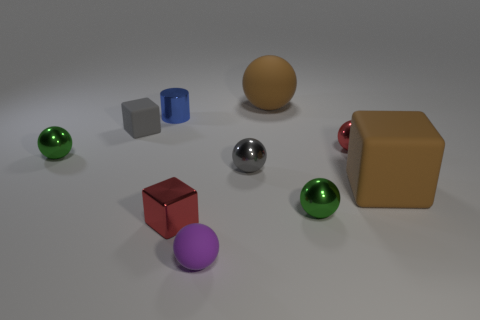Are there any other things that are the same shape as the blue metallic thing?
Make the answer very short. No. What is the size of the brown cube?
Offer a terse response. Large. Is the number of shiny cylinders that are on the right side of the large brown sphere less than the number of yellow cylinders?
Make the answer very short. No. Does the small cylinder have the same material as the small green sphere left of the tiny blue metallic cylinder?
Your response must be concise. Yes. Are there any large brown matte things in front of the rubber cube behind the green ball behind the gray metal ball?
Ensure brevity in your answer.  Yes. What is the color of the tiny cylinder that is made of the same material as the tiny red ball?
Your answer should be compact. Blue. There is a thing that is on the left side of the large matte sphere and on the right side of the tiny purple rubber object; how big is it?
Give a very brief answer. Small. Is the number of small metal cylinders behind the small cylinder less than the number of tiny red metallic objects left of the tiny rubber ball?
Provide a short and direct response. Yes. Are the big ball that is right of the cylinder and the tiny gray object left of the small purple matte ball made of the same material?
Make the answer very short. Yes. There is a block that is the same color as the big matte ball; what is it made of?
Keep it short and to the point. Rubber. 